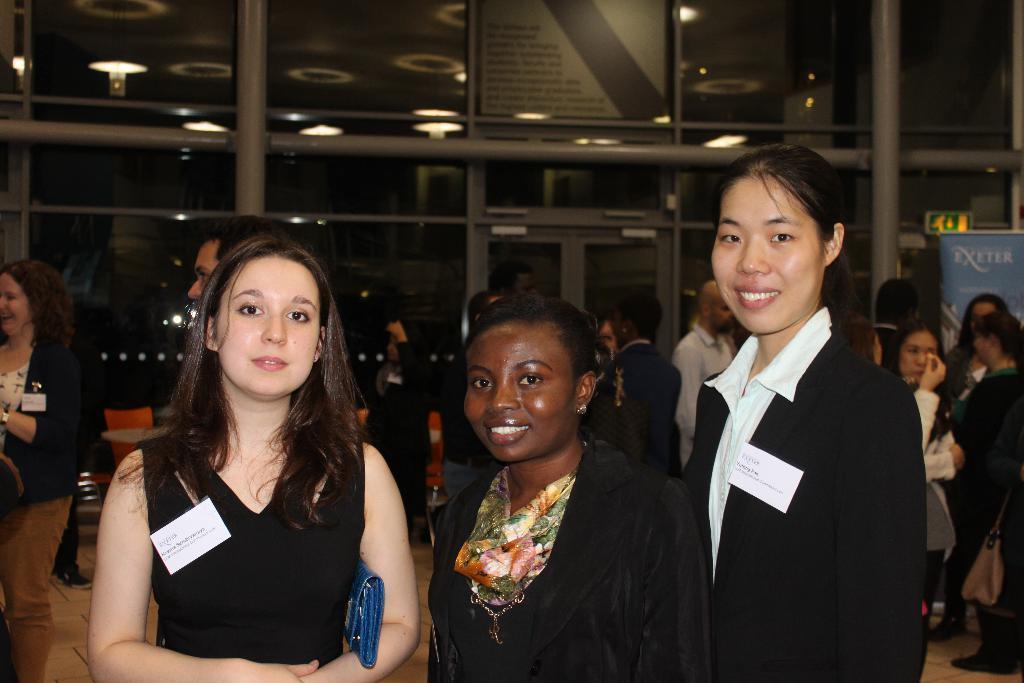Could you give a brief overview of what you see in this image? This picture is taken inside the room. In this image, in the middle, we can see three women are wearing a black color dress is stunning. On the left side, we can see a woman wearing a black color dress and holding a blue color purse in her hand. In the background, we can see a group of people, glass, door, glass window and a board. At the top, we can see a roof with few lights. 